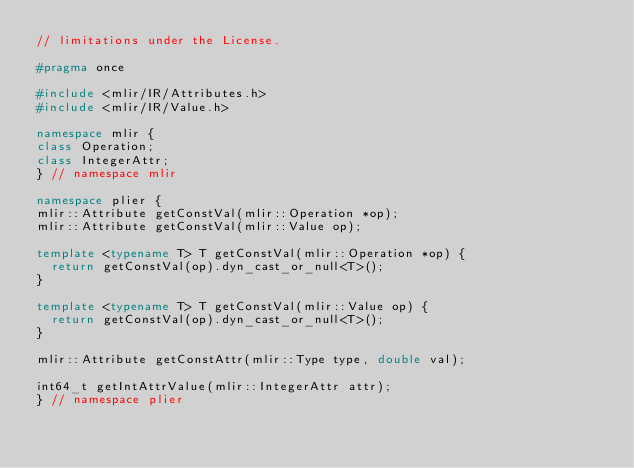<code> <loc_0><loc_0><loc_500><loc_500><_C++_>// limitations under the License.

#pragma once

#include <mlir/IR/Attributes.h>
#include <mlir/IR/Value.h>

namespace mlir {
class Operation;
class IntegerAttr;
} // namespace mlir

namespace plier {
mlir::Attribute getConstVal(mlir::Operation *op);
mlir::Attribute getConstVal(mlir::Value op);

template <typename T> T getConstVal(mlir::Operation *op) {
  return getConstVal(op).dyn_cast_or_null<T>();
}

template <typename T> T getConstVal(mlir::Value op) {
  return getConstVal(op).dyn_cast_or_null<T>();
}

mlir::Attribute getConstAttr(mlir::Type type, double val);

int64_t getIntAttrValue(mlir::IntegerAttr attr);
} // namespace plier
</code> 